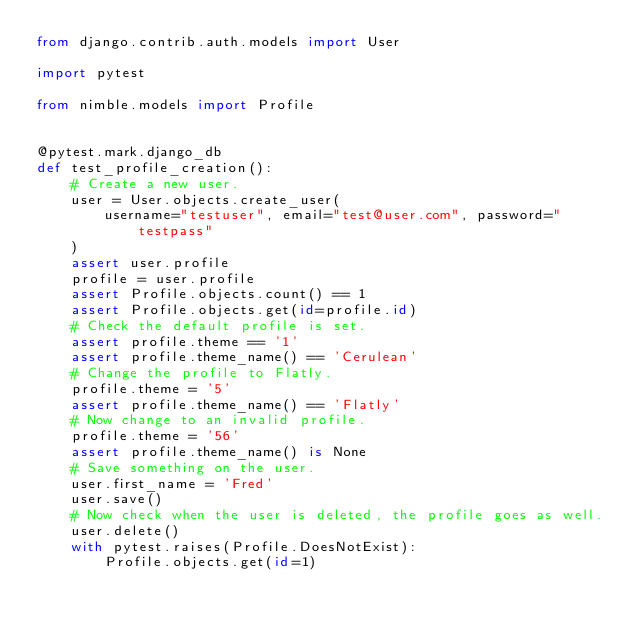<code> <loc_0><loc_0><loc_500><loc_500><_Python_>from django.contrib.auth.models import User

import pytest

from nimble.models import Profile


@pytest.mark.django_db
def test_profile_creation():
    # Create a new user.
    user = User.objects.create_user(
        username="testuser", email="test@user.com", password="testpass"
    )
    assert user.profile
    profile = user.profile
    assert Profile.objects.count() == 1
    assert Profile.objects.get(id=profile.id)
    # Check the default profile is set.
    assert profile.theme == '1'
    assert profile.theme_name() == 'Cerulean'
    # Change the profile to Flatly.
    profile.theme = '5'
    assert profile.theme_name() == 'Flatly'
    # Now change to an invalid profile.
    profile.theme = '56'
    assert profile.theme_name() is None
    # Save something on the user.
    user.first_name = 'Fred'
    user.save()
    # Now check when the user is deleted, the profile goes as well.
    user.delete()
    with pytest.raises(Profile.DoesNotExist):
        Profile.objects.get(id=1)
</code> 